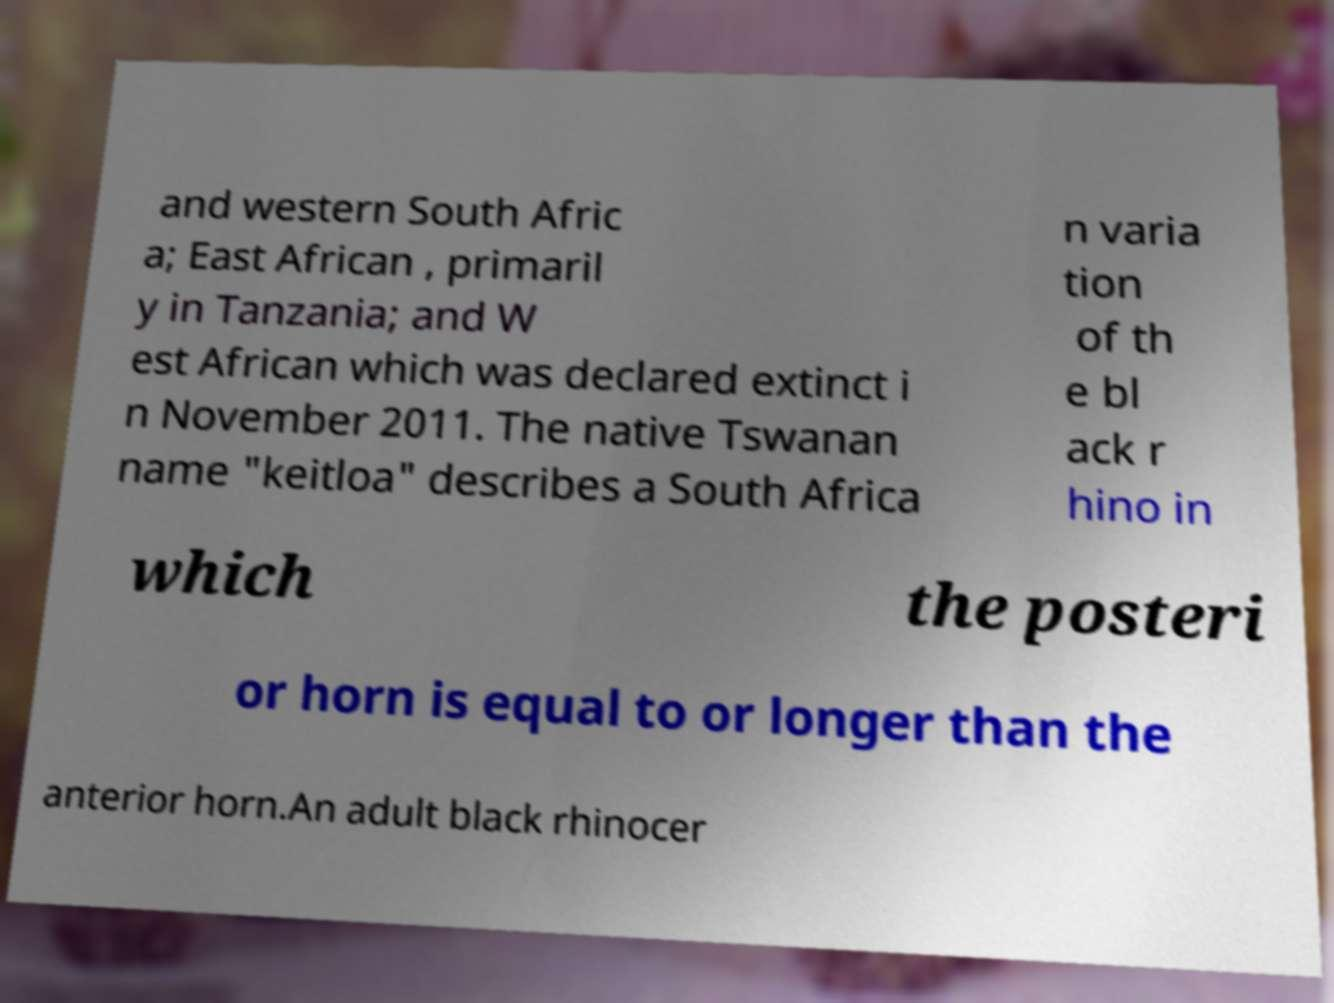Could you extract and type out the text from this image? and western South Afric a; East African , primaril y in Tanzania; and W est African which was declared extinct i n November 2011. The native Tswanan name "keitloa" describes a South Africa n varia tion of th e bl ack r hino in which the posteri or horn is equal to or longer than the anterior horn.An adult black rhinocer 